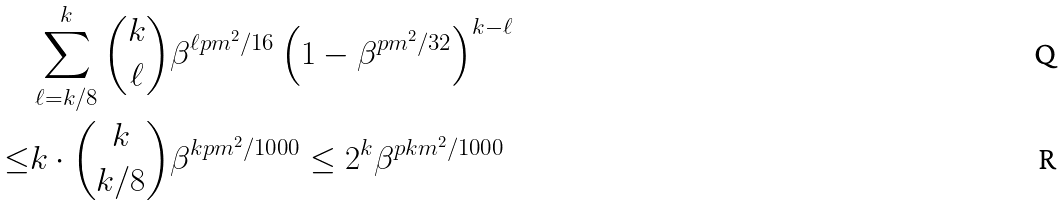Convert formula to latex. <formula><loc_0><loc_0><loc_500><loc_500>& \sum _ { \ell = k / 8 } ^ { k } \binom { k } { \ell } \beta ^ { \ell p m ^ { 2 } / 1 6 } \left ( 1 - \beta ^ { p m ^ { 2 } / 3 2 } \right ) ^ { k - \ell } \\ \leq & k \cdot \binom { k } { k / 8 } \beta ^ { k p m ^ { 2 } / 1 0 0 0 } \leq 2 ^ { k } \beta ^ { p k m ^ { 2 } / 1 0 0 0 }</formula> 